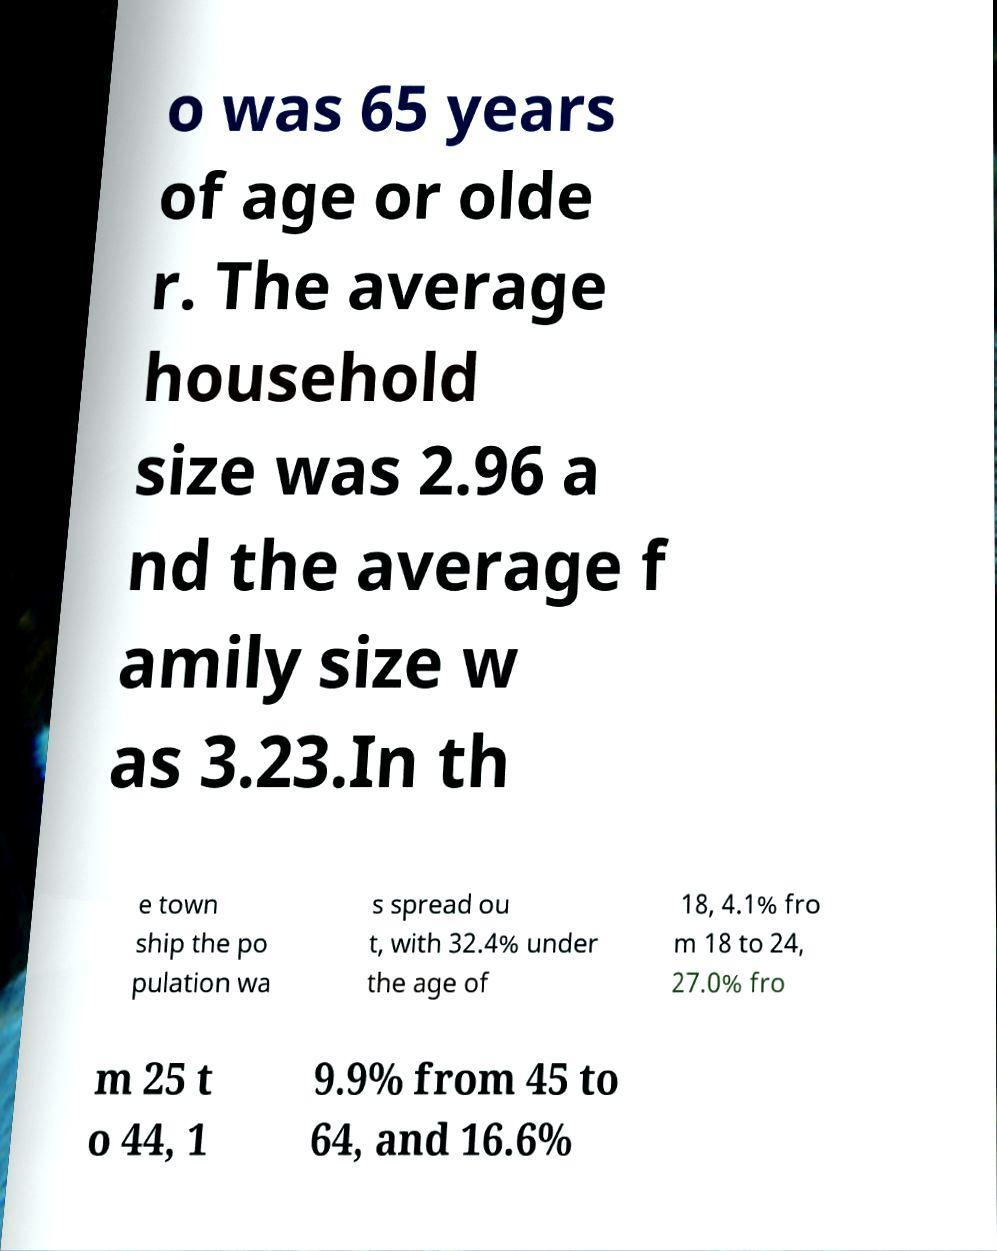Please read and relay the text visible in this image. What does it say? o was 65 years of age or olde r. The average household size was 2.96 a nd the average f amily size w as 3.23.In th e town ship the po pulation wa s spread ou t, with 32.4% under the age of 18, 4.1% fro m 18 to 24, 27.0% fro m 25 t o 44, 1 9.9% from 45 to 64, and 16.6% 